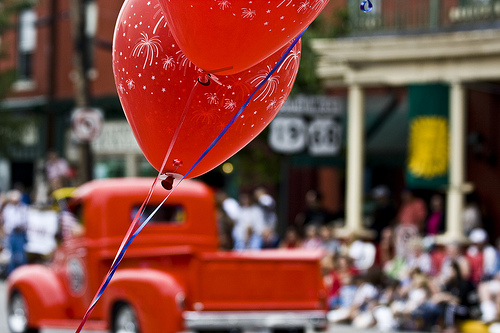<image>
Is the balloon on the truck? No. The balloon is not positioned on the truck. They may be near each other, but the balloon is not supported by or resting on top of the truck. 